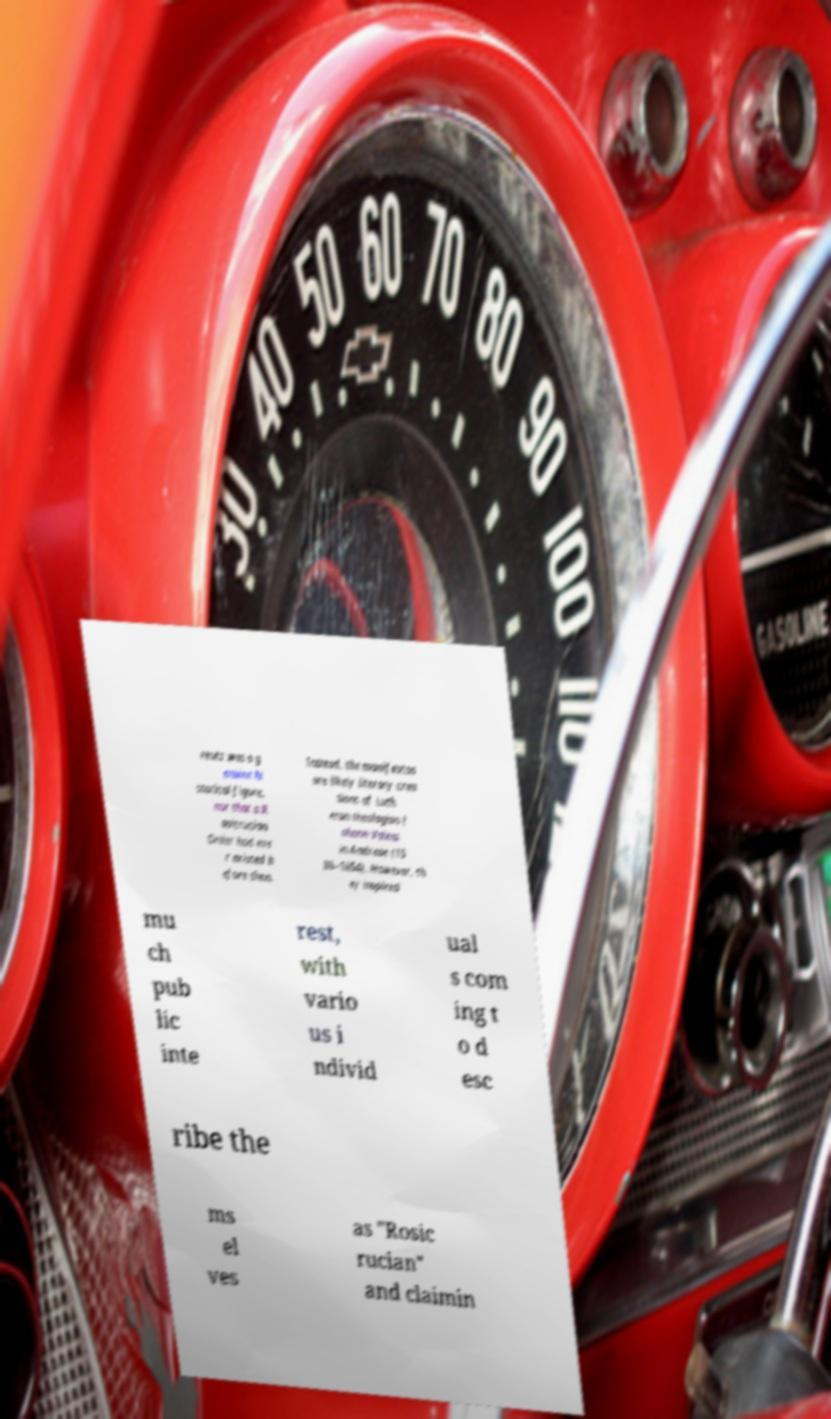Can you read and provide the text displayed in the image?This photo seems to have some interesting text. Can you extract and type it out for me? reutz was a g enuine hi storical figure, nor that a R osicrucian Order had eve r existed b efore then. Instead, the manifestos are likely literary crea tions of Luth eran theologian J ohann Valent in Andreae (15 86–1654). However, th ey inspired mu ch pub lic inte rest, with vario us i ndivid ual s com ing t o d esc ribe the ms el ves as "Rosic rucian" and claimin 